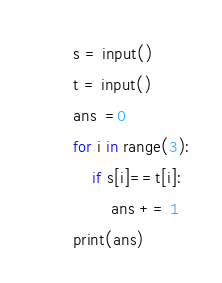<code> <loc_0><loc_0><loc_500><loc_500><_Python_>s = input()
t = input()
ans  =0
for i in range(3):
	if s[i]==t[i]:
		ans += 1
print(ans)</code> 